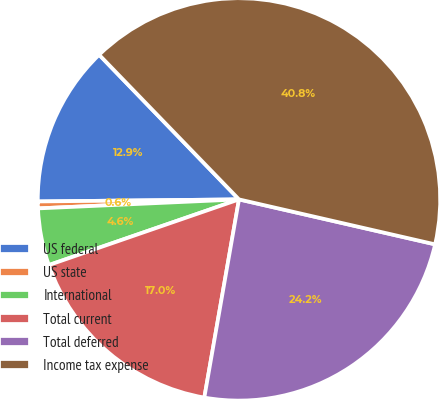Convert chart to OTSL. <chart><loc_0><loc_0><loc_500><loc_500><pie_chart><fcel>US federal<fcel>US state<fcel>International<fcel>Total current<fcel>Total deferred<fcel>Income tax expense<nl><fcel>12.93%<fcel>0.55%<fcel>4.58%<fcel>16.95%<fcel>24.17%<fcel>40.82%<nl></chart> 